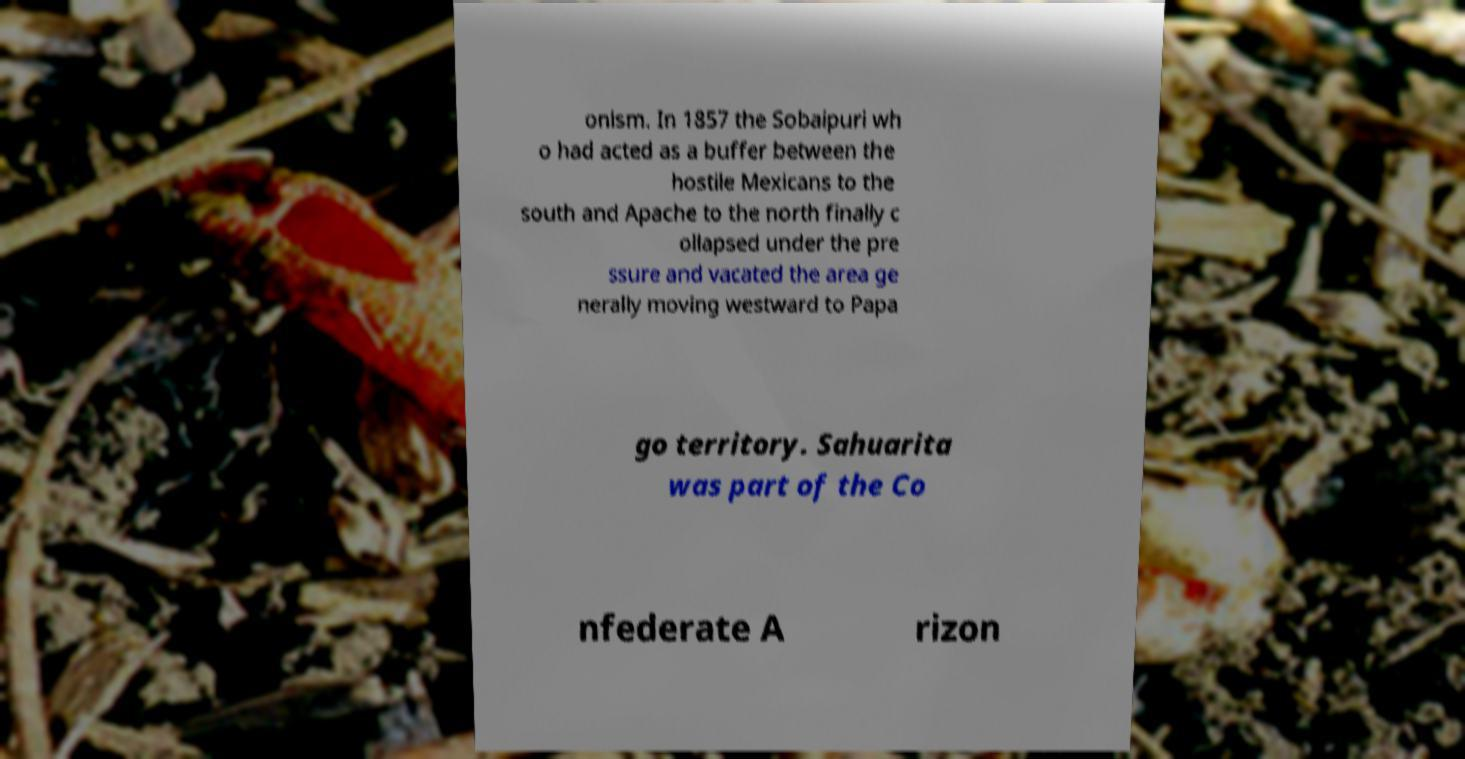For documentation purposes, I need the text within this image transcribed. Could you provide that? onism. In 1857 the Sobaipuri wh o had acted as a buffer between the hostile Mexicans to the south and Apache to the north finally c ollapsed under the pre ssure and vacated the area ge nerally moving westward to Papa go territory. Sahuarita was part of the Co nfederate A rizon 